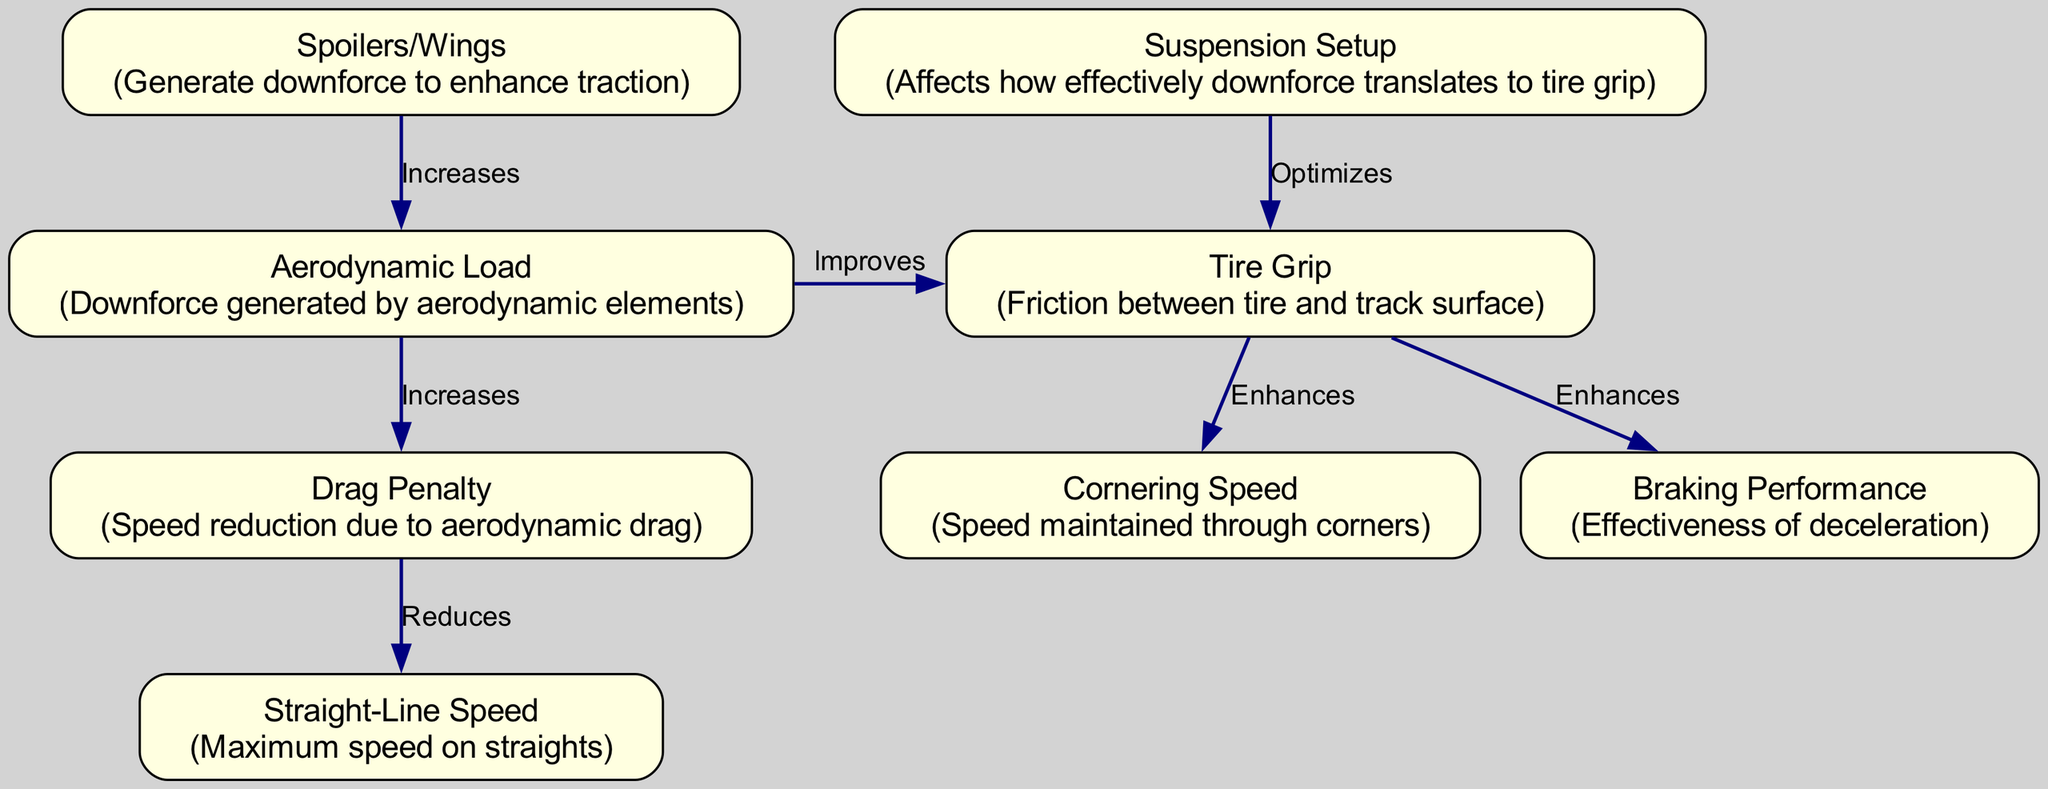What is the main source of aerodynamic load? The diagram indicates that spoilers and wings generate aerodynamic load, providing a direct link between these components and the aerodynamic load node.
Answer: Spoilers/Wings How does aerodynamic load affect tire grip? There is a direct edge labeled "Improves" connecting aerodynamic load to tire grip, which shows that an increase in aerodynamic load leads to better tire grip.
Answer: Improves Which node is optimized by suspension setup? The suspension setup directly influences tire grip as indicated by the edge labeled "Optimizes" pointing to tire grip.
Answer: Tire Grip How many nodes are in the diagram? By counting all the unique nodes shown, we find there are a total of eight distinct nodes that represent different concepts related to aerodynamic load and tire grip.
Answer: Eight What effect does drag penalty have on straight-line speed? The diagram displays a connection where drag penalty "Reduces" straight-line speed, revealing a cause-and-effect relationship between these two nodes.
Answer: Reduces What relationship exists between tire grip and cornering speed? The edge labeled "Enhances" between tire grip and cornering speed indicates that an increase in tire grip will lead to higher cornering speeds.
Answer: Enhances If aerodynamic load increases, what happens to drag penalty? The diagram shows a direct link where an increase in aerodynamic load "Increases" drag penalty, suggesting they move in the same direction.
Answer: Increases What is affected by both tire grip and drag penalty? The diagram connects tire grip to both cornering speed and braking performance with "Enhances", while drag penalty directly affects straight-line speed. The question asks for the common influence which is seen in tire grip.
Answer: Tire Grip How does suspension setup directly impact tire grip? The edge in the diagram indicates that suspension setup "Optimizes" the tire grip, implying that specific adjustments to the suspension can lead to improved grip on the track.
Answer: Optimizes 